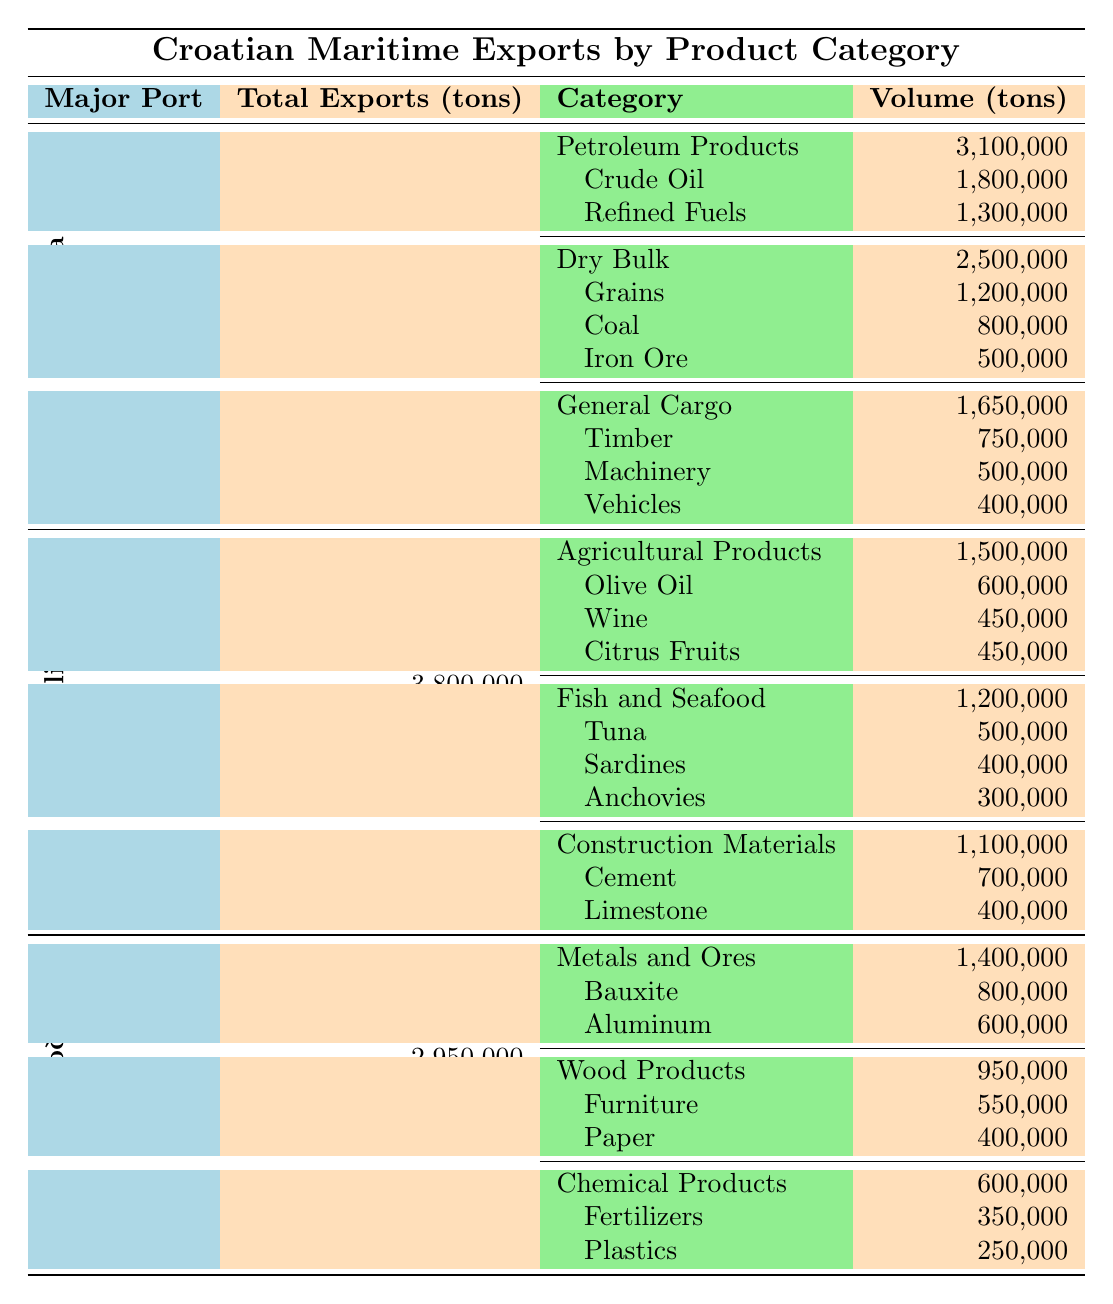What is the total export volume of Petroleum Products from Rijeka? The table shows that the total volume of Petroleum Products exported from Rijeka is listed as 3,100,000 tons.
Answer: 3,100,000 tons Which port has the highest total export volume? By comparing the total exports from Rijeka (7,250,000 tons), Split (3,800,000 tons), and Ploče (2,950,000 tons), Rijeka has the highest total export volume.
Answer: Rijeka How much do agricultural products contribute to the total exports from Split? The table specifies that agricultural products account for 1,500,000 tons of the total exports from Split (3,800,000 tons). Thus, this category contributes about 39.47% (1,500,000 / 3,800,000) of the total exports.
Answer: 39.47% What is the combined volume of Grains and Coal exported from Rijeka? The volume of Grains exported is 1,200,000 tons, and Coal is 800,000 tons. Adding these together gives 1,200,000 + 800,000 = 2,000,000 tons.
Answer: 2,000,000 tons How many product categories are present in the export data for Ploče? The table indicates that there are three distinct product categories listed under Ploče: Metals and Ores, Wood Products, and Chemical Products.
Answer: 3 Is the total export volume for Split greater than the combined total for Rijeka and Ploče? The total exports for Split (3,800,000 tons) are less than the combined total of Rijeka (7,250,000 tons) and Ploče (2,950,000 tons), which is 10,200,000 tons. Therefore, the statement is false.
Answer: No Which subcategory had the highest export volume in Rijeka? The largest subcategory in Rijeka is Petroleum Products, specifically Crude Oil, with an export volume of 1,800,000 tons.
Answer: Crude Oil What percentage of the total exports from Ploče comes from Metals and Ores? Metals and Ores account for 1,400,000 tons from Ploče's total exports of 2,950,000 tons. Calculating the percentage gives (1,400,000 / 2,950,000) * 100 ≈ 47.45%.
Answer: 47.45% Are there more products exported from Split than from Rijeka? Rijeka exports eight distinct products (in several categories), whereas Split has seven products listed. Thus, there are more products exported from Rijeka than from Split.
Answer: No Calculate the total volume of Fish and Seafood exported from Split. The total export volume of Fish and Seafood from Split is the sum of Tuna (500,000 tons), Sardines (400,000 tons), and Anchovies (300,000 tons), which equals 1,200,000 tons.
Answer: 1,200,000 tons 